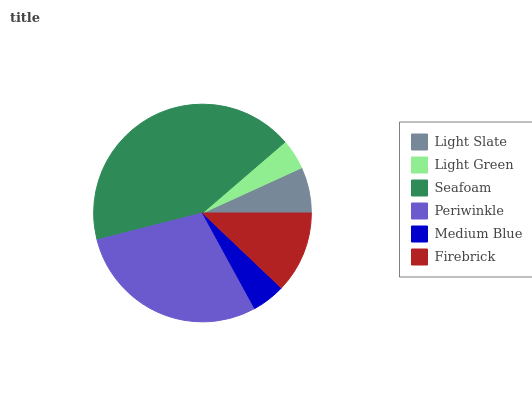Is Light Green the minimum?
Answer yes or no. Yes. Is Seafoam the maximum?
Answer yes or no. Yes. Is Seafoam the minimum?
Answer yes or no. No. Is Light Green the maximum?
Answer yes or no. No. Is Seafoam greater than Light Green?
Answer yes or no. Yes. Is Light Green less than Seafoam?
Answer yes or no. Yes. Is Light Green greater than Seafoam?
Answer yes or no. No. Is Seafoam less than Light Green?
Answer yes or no. No. Is Firebrick the high median?
Answer yes or no. Yes. Is Light Slate the low median?
Answer yes or no. Yes. Is Periwinkle the high median?
Answer yes or no. No. Is Seafoam the low median?
Answer yes or no. No. 